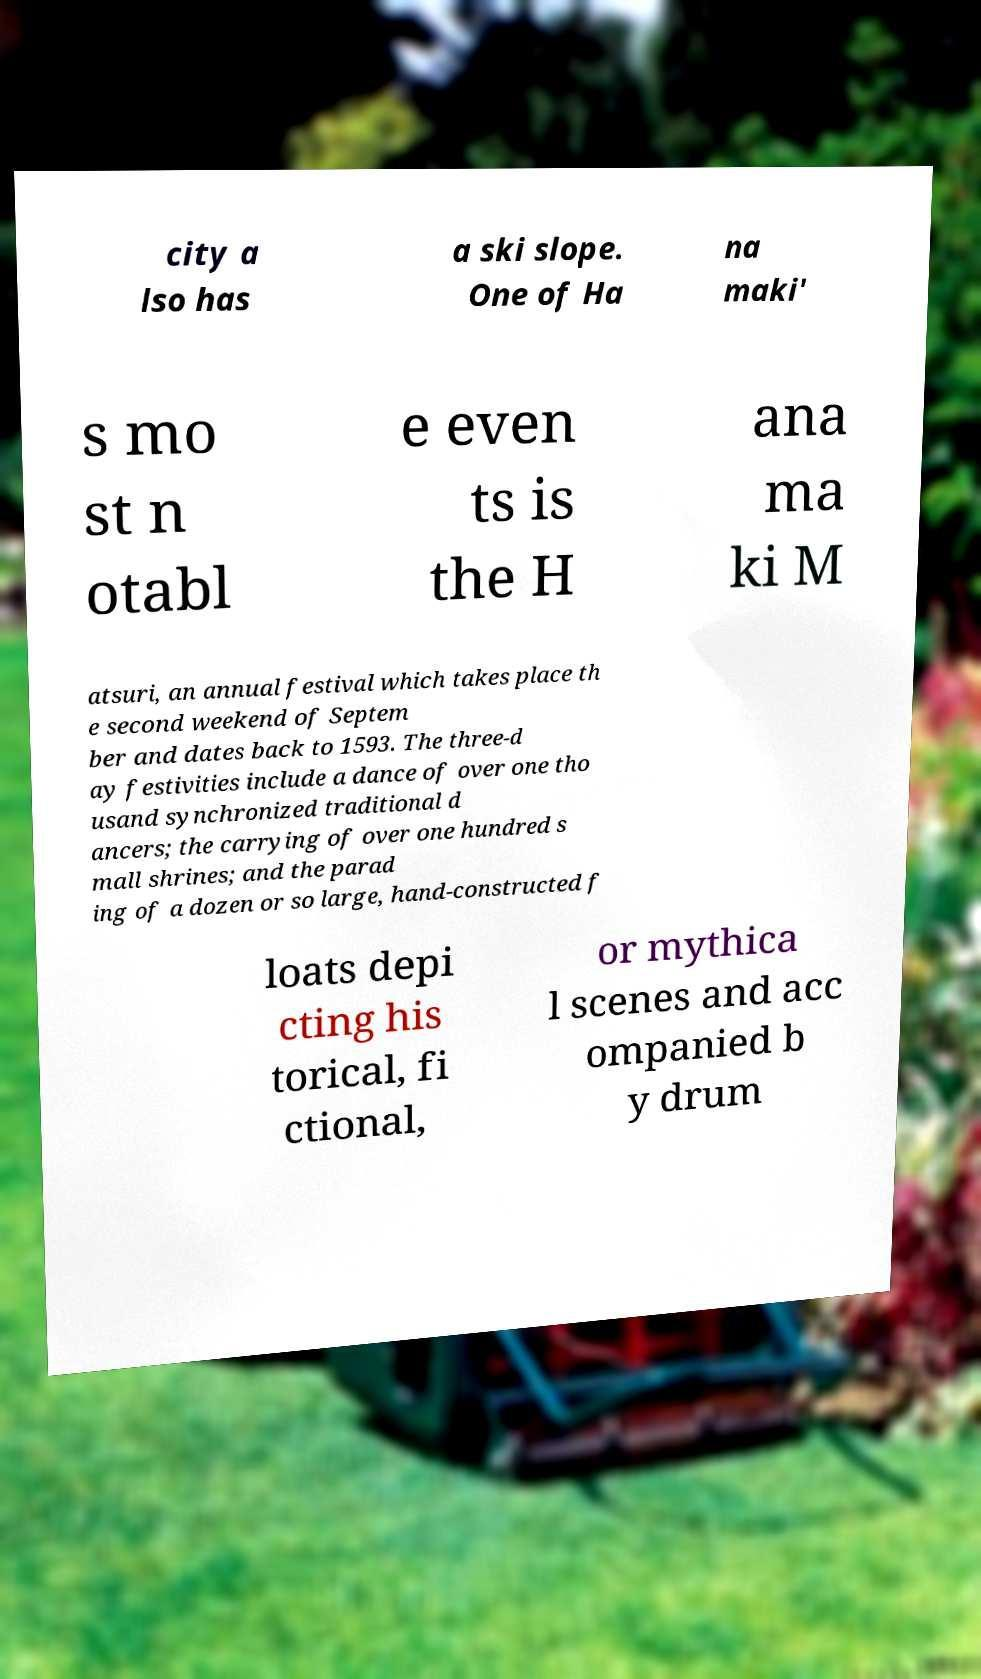For documentation purposes, I need the text within this image transcribed. Could you provide that? city a lso has a ski slope. One of Ha na maki' s mo st n otabl e even ts is the H ana ma ki M atsuri, an annual festival which takes place th e second weekend of Septem ber and dates back to 1593. The three-d ay festivities include a dance of over one tho usand synchronized traditional d ancers; the carrying of over one hundred s mall shrines; and the parad ing of a dozen or so large, hand-constructed f loats depi cting his torical, fi ctional, or mythica l scenes and acc ompanied b y drum 